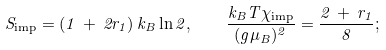<formula> <loc_0><loc_0><loc_500><loc_500>S _ { \text {imp} } = ( 1 \, + \, 2 r _ { 1 } ) \, k _ { B } \ln 2 , \quad \frac { k _ { B } T \chi _ { \text {imp} } } { ( g \mu _ { B } ) ^ { 2 } } = \frac { 2 \, + \, r _ { 1 } } { 8 } ;</formula> 